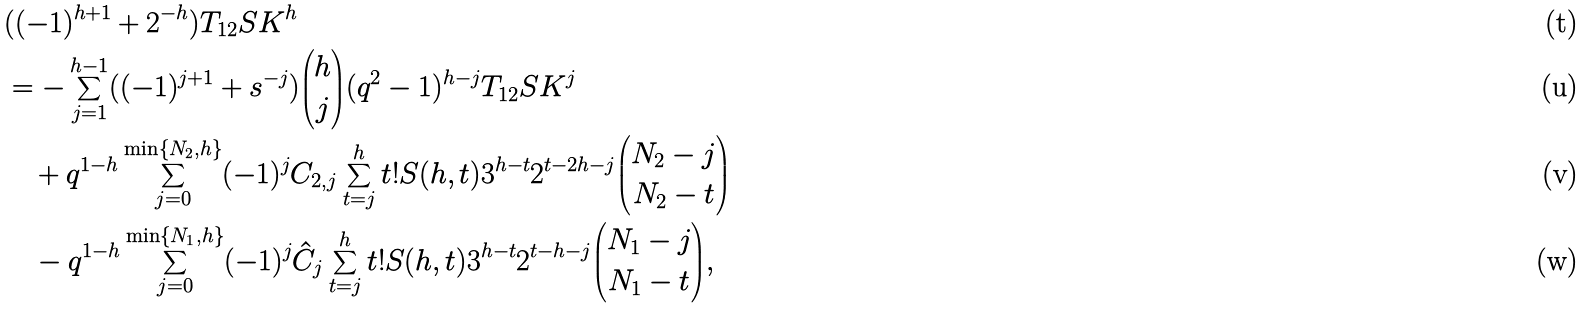Convert formula to latex. <formula><loc_0><loc_0><loc_500><loc_500>& ( ( - 1 ) ^ { h + 1 } + 2 ^ { - h } ) T _ { 1 2 } S K ^ { h } \\ & = - \sum _ { j = 1 } ^ { h - 1 } ( ( - 1 ) ^ { j + 1 } + s ^ { - j } ) { \binom { h } { j } } ( q ^ { 2 } - 1 ) ^ { h - j } T _ { 1 2 } S K ^ { j } \\ & \quad + q ^ { 1 - h } \sum _ { j = 0 } ^ { \min \{ N _ { 2 } , h \} } ( - 1 ) ^ { j } C _ { 2 , j } \sum _ { t = j } ^ { h } t ! S ( h , t ) 3 ^ { h - t } 2 ^ { t - 2 h - j } { \binom { N _ { 2 } - j } { N _ { 2 } - t } } \\ & \quad - q ^ { 1 - h } \sum _ { j = 0 } ^ { \min \{ N _ { 1 } , h \} } ( - 1 ) ^ { j } \hat { C } _ { j } \sum _ { t = j } ^ { h } t ! S ( h , t ) 3 ^ { h - t } 2 ^ { t - h - j } { \binom { N _ { 1 } - j } { N _ { 1 } - t } } ,</formula> 